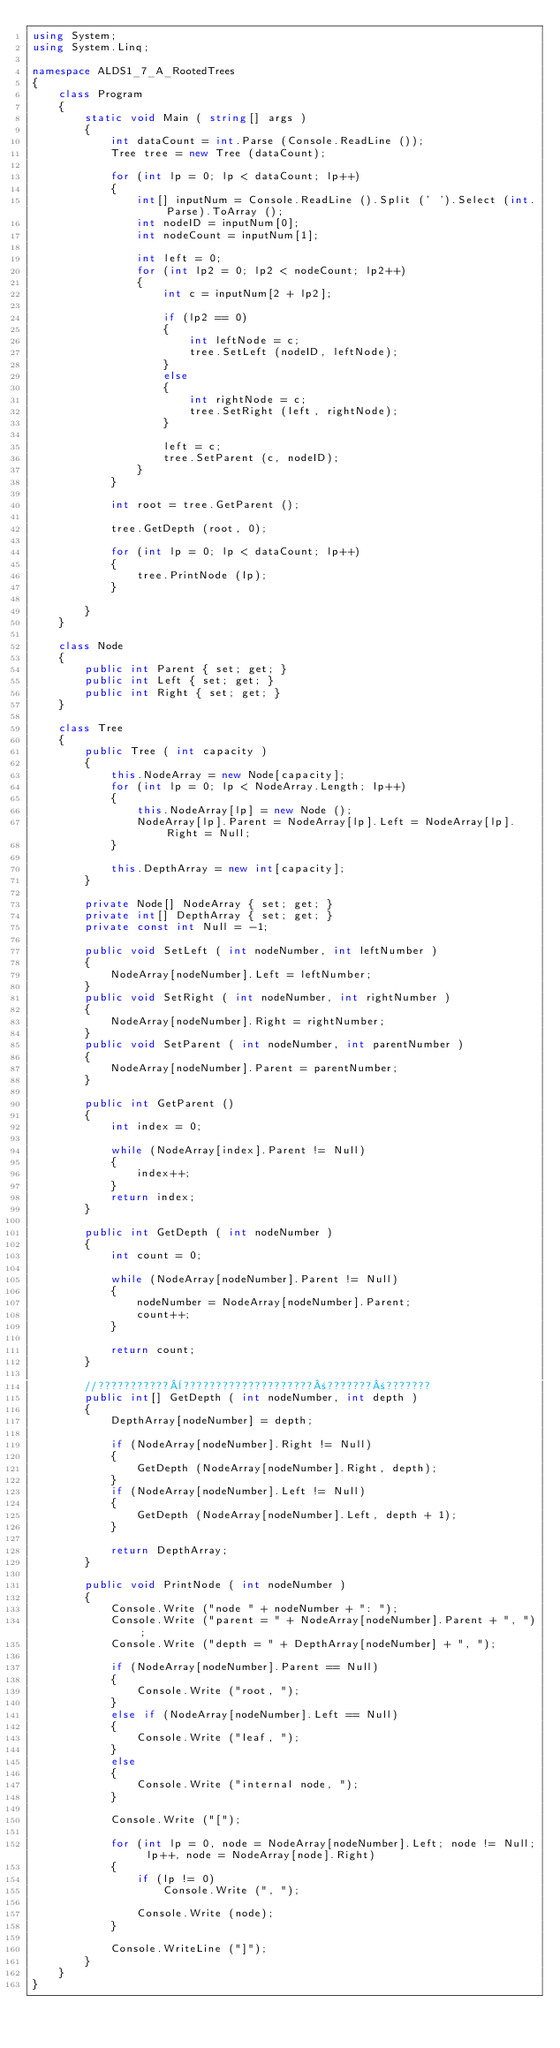<code> <loc_0><loc_0><loc_500><loc_500><_C#_>using System;
using System.Linq;

namespace ALDS1_7_A_RootedTrees
{
	class Program
	{
		static void Main ( string[] args )
		{
			int dataCount = int.Parse (Console.ReadLine ());
			Tree tree = new Tree (dataCount);

			for (int lp = 0; lp < dataCount; lp++)
			{
				int[] inputNum = Console.ReadLine ().Split (' ').Select (int.Parse).ToArray ();
				int nodeID = inputNum[0];
				int nodeCount = inputNum[1];

				int left = 0;
				for (int lp2 = 0; lp2 < nodeCount; lp2++)
				{
					int c = inputNum[2 + lp2];

					if (lp2 == 0)
					{
						int leftNode = c;
						tree.SetLeft (nodeID, leftNode);
					}
					else
					{
						int rightNode = c;
						tree.SetRight (left, rightNode);
					}

					left = c;
					tree.SetParent (c, nodeID);
				}
			}

			int root = tree.GetParent ();

			tree.GetDepth (root, 0);

			for (int lp = 0; lp < dataCount; lp++)
			{
				tree.PrintNode (lp);
			}

		}
	}

	class Node
	{
		public int Parent { set; get; }
		public int Left { set; get; }
		public int Right { set; get; }
	}

	class Tree
	{
		public Tree ( int capacity )
		{
			this.NodeArray = new Node[capacity];
			for (int lp = 0; lp < NodeArray.Length; lp++)
			{
				this.NodeArray[lp] = new Node ();
				NodeArray[lp].Parent = NodeArray[lp].Left = NodeArray[lp].Right = Null;
			}

			this.DepthArray = new int[capacity];
		}

		private Node[] NodeArray { set; get; }
		private int[] DepthArray { set; get; }
		private const int Null = -1;

		public void SetLeft ( int nodeNumber, int leftNumber )
		{
			NodeArray[nodeNumber].Left = leftNumber;
		}
		public void SetRight ( int nodeNumber, int rightNumber )
		{
			NodeArray[nodeNumber].Right = rightNumber;
		}
		public void SetParent ( int nodeNumber, int parentNumber )
		{
			NodeArray[nodeNumber].Parent = parentNumber;
		}

		public int GetParent ()
		{
			int index = 0;

			while (NodeArray[index].Parent != Null)
			{
				index++;
			}
			return index;
		}

		public int GetDepth ( int nodeNumber )
		{
			int count = 0;

			while (NodeArray[nodeNumber].Parent != Null)
			{
				nodeNumber = NodeArray[nodeNumber].Parent;
				count++;
			}

			return count;
		}

		//???????????¨????????????????????±???????±???????
		public int[] GetDepth ( int nodeNumber, int depth )
		{
			DepthArray[nodeNumber] = depth;

			if (NodeArray[nodeNumber].Right != Null)
			{
				GetDepth (NodeArray[nodeNumber].Right, depth);
			}
			if (NodeArray[nodeNumber].Left != Null)
			{
				GetDepth (NodeArray[nodeNumber].Left, depth + 1);
			}

			return DepthArray;
		}

		public void PrintNode ( int nodeNumber )
		{
			Console.Write ("node " + nodeNumber + ": ");
			Console.Write ("parent = " + NodeArray[nodeNumber].Parent + ", ");
			Console.Write ("depth = " + DepthArray[nodeNumber] + ", ");

			if (NodeArray[nodeNumber].Parent == Null)
			{
				Console.Write ("root, ");
			}
			else if (NodeArray[nodeNumber].Left == Null)
			{
				Console.Write ("leaf, ");
			}
			else
			{
				Console.Write ("internal node, ");
			}

			Console.Write ("[");

			for (int lp = 0, node = NodeArray[nodeNumber].Left; node != Null; lp++, node = NodeArray[node].Right)
			{
				if (lp != 0)
					Console.Write (", ");

				Console.Write (node);
			}

			Console.WriteLine ("]");
		}
	}
}</code> 